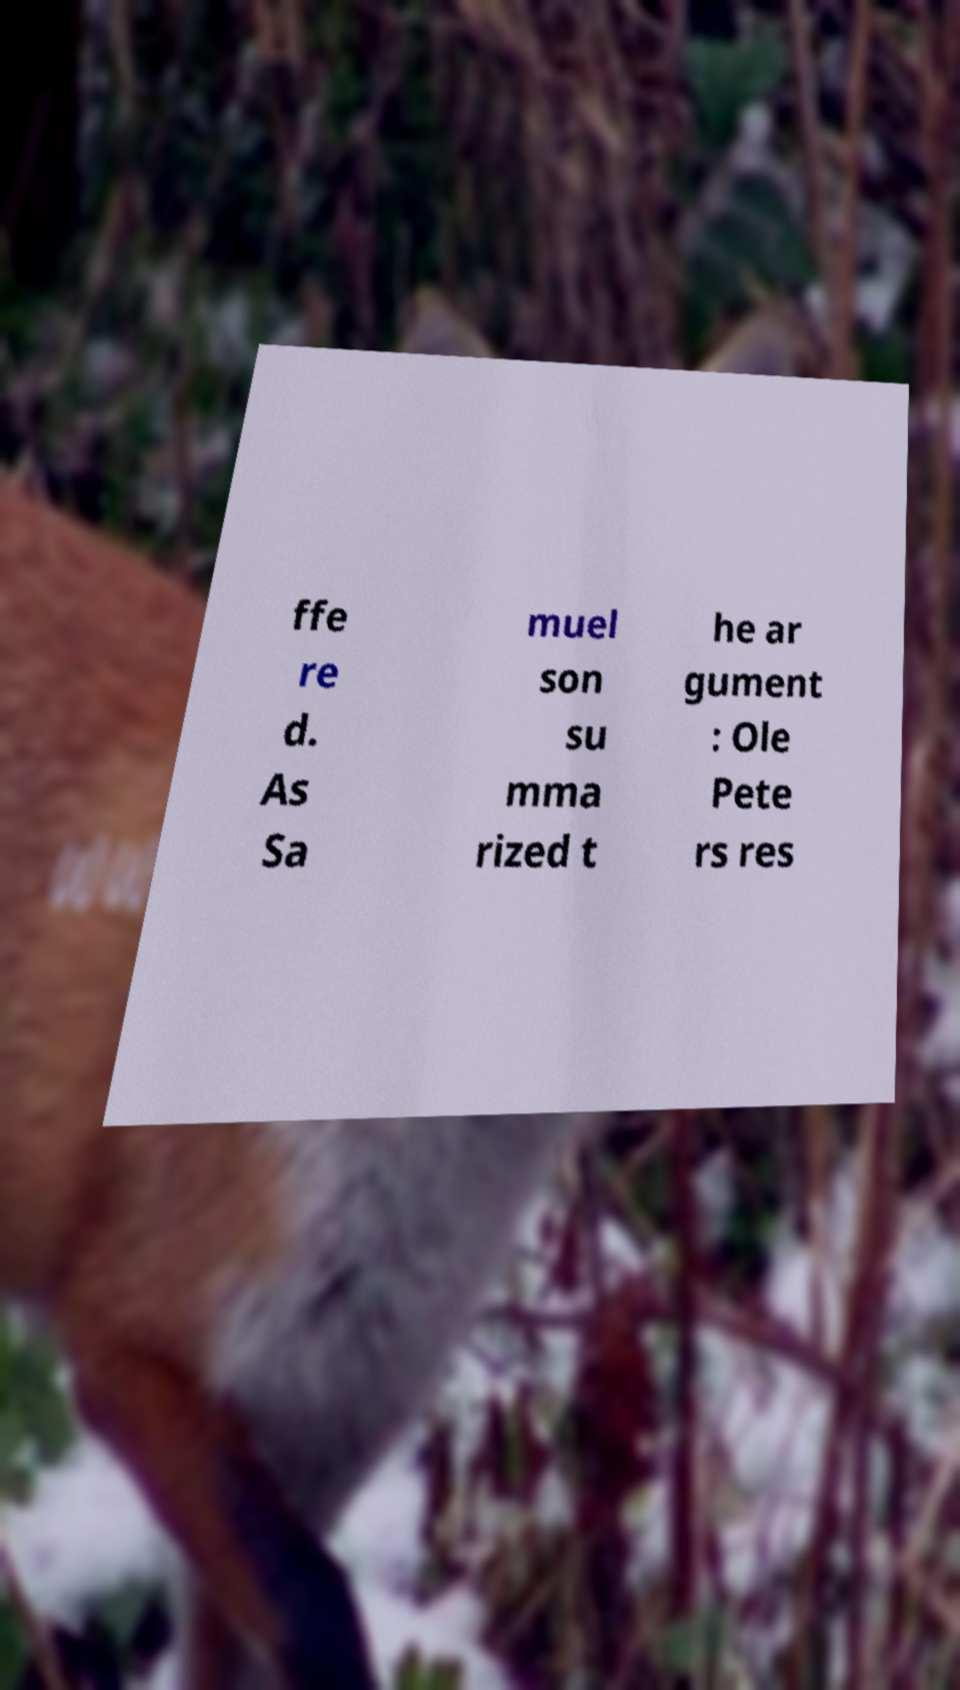What messages or text are displayed in this image? I need them in a readable, typed format. ffe re d. As Sa muel son su mma rized t he ar gument : Ole Pete rs res 